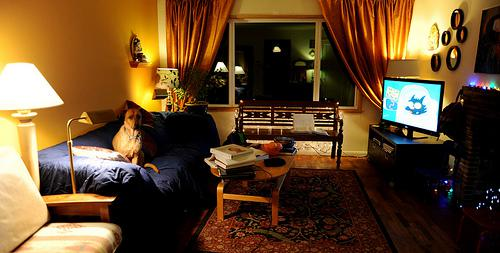Question: what kind of animal is in the photo?
Choices:
A. Cat.
B. Horse.
C. Cow.
D. Dog.
Answer with the letter. Answer: D Question: when is this scene taking place?
Choices:
A. During the day.
B. At dawn.
C. Nighttime.
D. At dusk.
Answer with the letter. Answer: C Question: what is on top of the rug in front of the sofa?
Choices:
A. Desk.
B. End table.
C. Television table.
D. Coffee table.
Answer with the letter. Answer: D Question: where is this scene taking place?
Choices:
A. In a bathroom.
B. In a living room.
C. In a kitchen.
D. In a bedroom.
Answer with the letter. Answer: B 